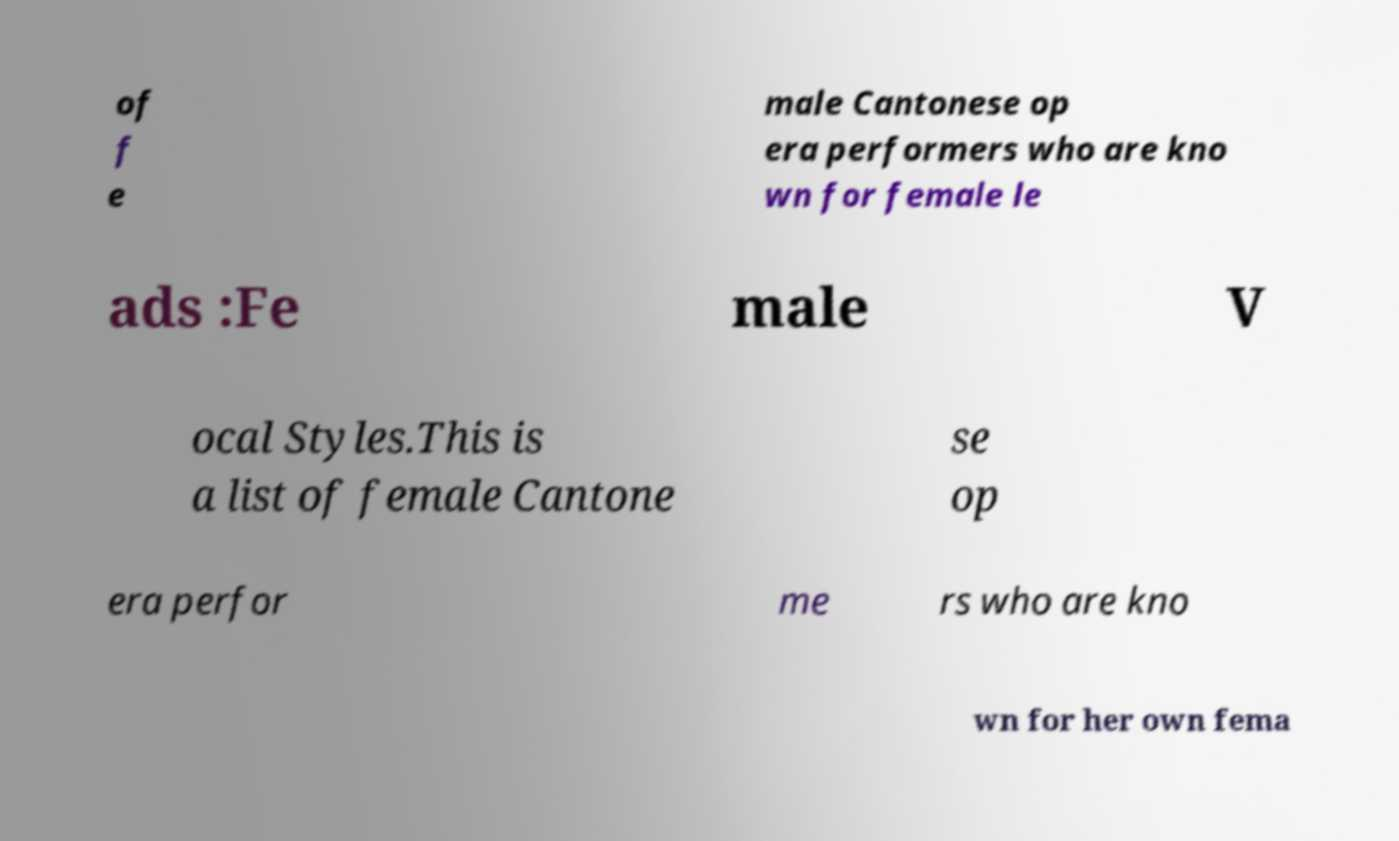Please identify and transcribe the text found in this image. of f e male Cantonese op era performers who are kno wn for female le ads :Fe male V ocal Styles.This is a list of female Cantone se op era perfor me rs who are kno wn for her own fema 